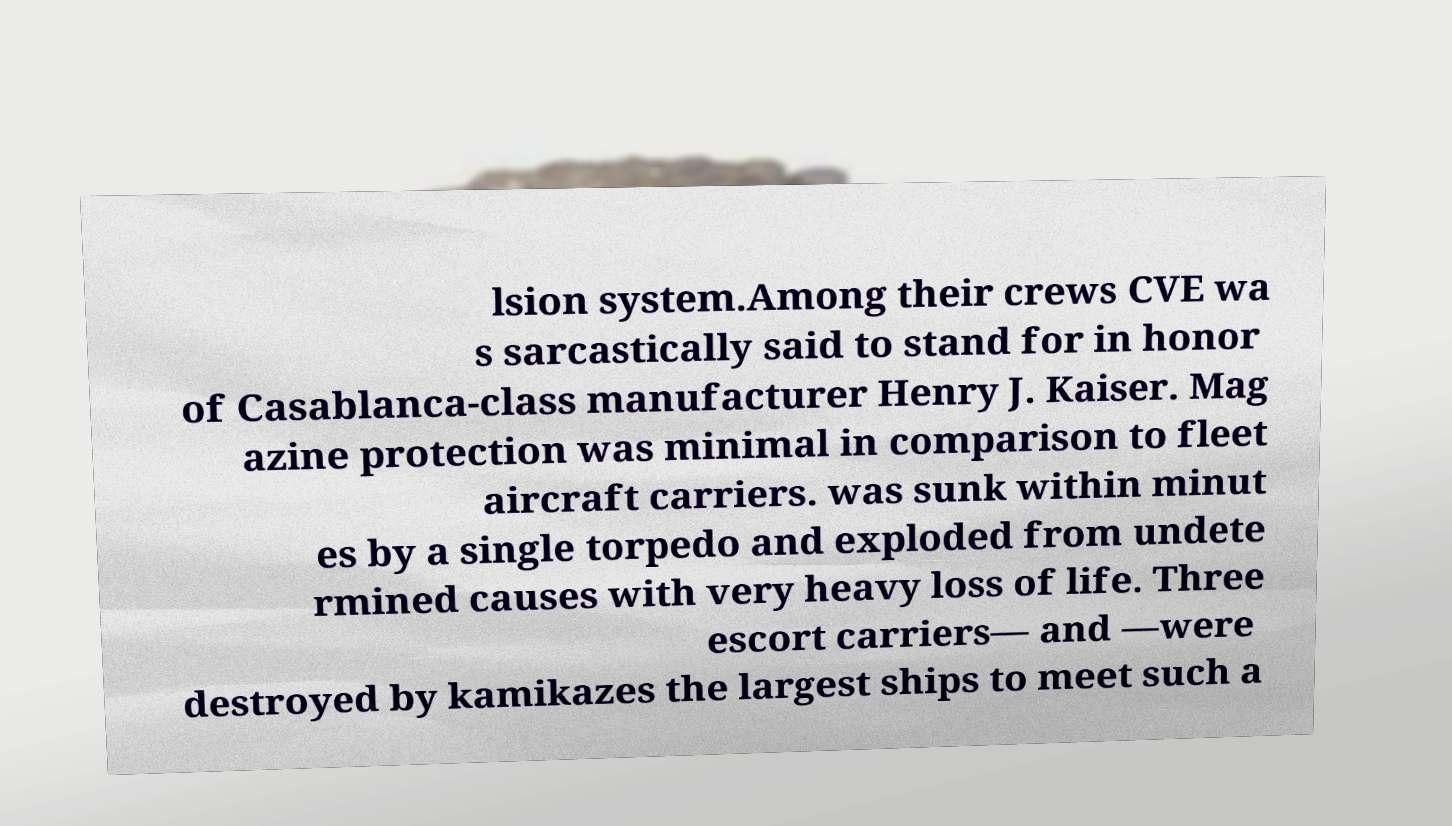I need the written content from this picture converted into text. Can you do that? lsion system.Among their crews CVE wa s sarcastically said to stand for in honor of Casablanca-class manufacturer Henry J. Kaiser. Mag azine protection was minimal in comparison to fleet aircraft carriers. was sunk within minut es by a single torpedo and exploded from undete rmined causes with very heavy loss of life. Three escort carriers— and —were destroyed by kamikazes the largest ships to meet such a 